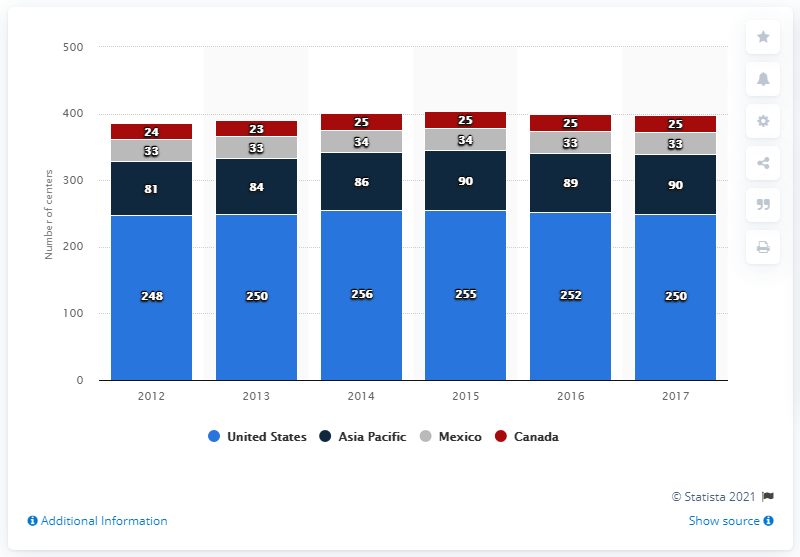List a handful of essential elements in this visual. The last time that there were convention centers in the United States, Mexico, Canada, and Asia Pacific was in 2012. There were 89 convention centers in the Asia Pacific region in 2016. In 2016, there were 25 convention centers in Canada. 